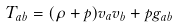<formula> <loc_0><loc_0><loc_500><loc_500>T _ { a b } = ( \rho + p ) v _ { a } v _ { b } + p g _ { a b }</formula> 